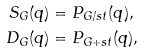Convert formula to latex. <formula><loc_0><loc_0><loc_500><loc_500>S _ { G } ( q ) & = P _ { G / s t } ( q ) , \\ D _ { G } ( q ) & = P _ { G + s t } ( q ) ,</formula> 